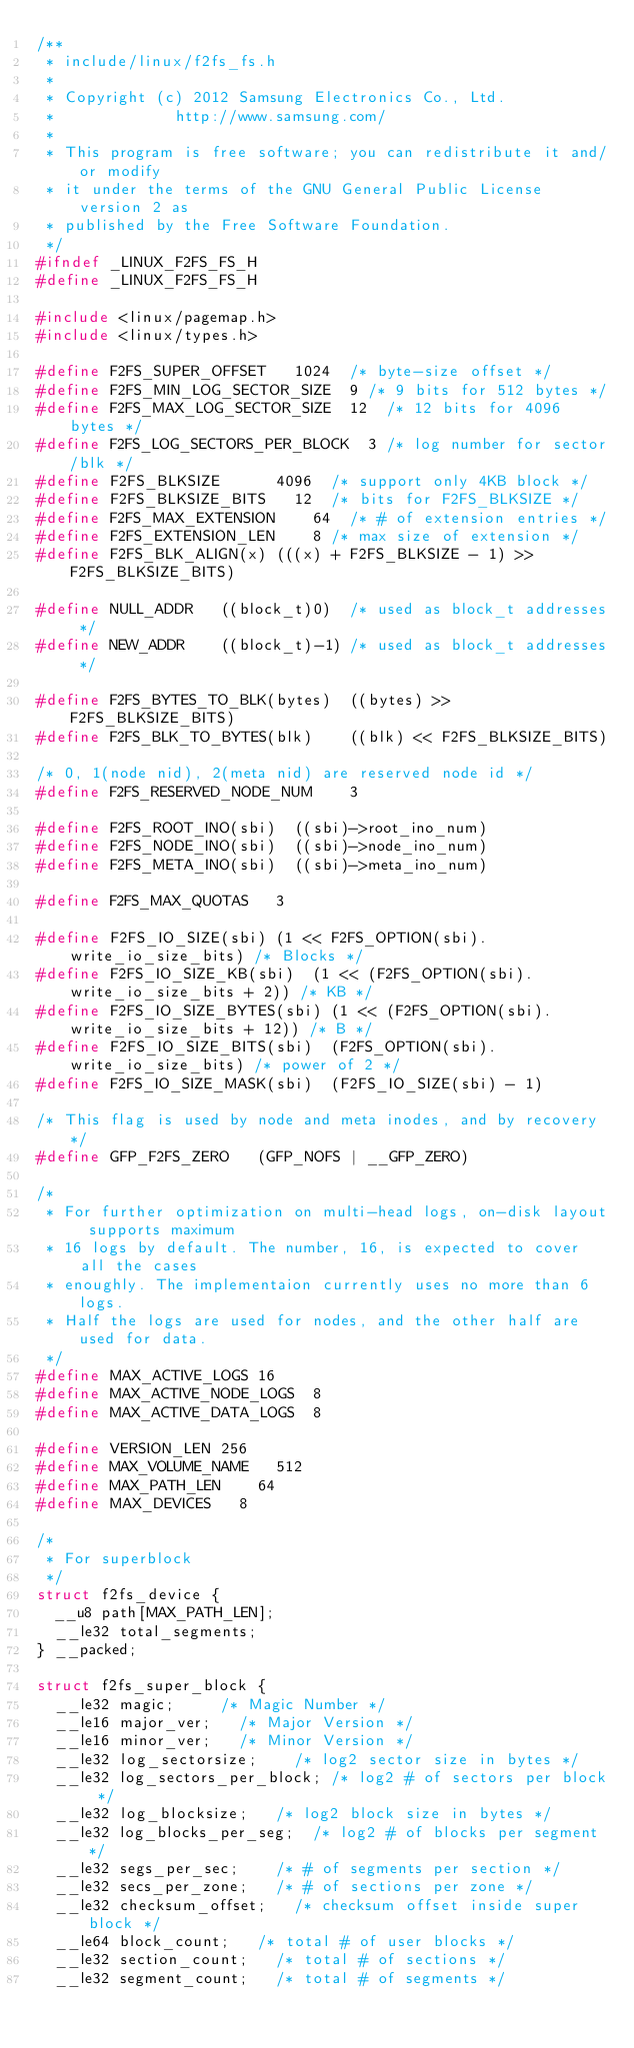Convert code to text. <code><loc_0><loc_0><loc_500><loc_500><_C_>/**
 * include/linux/f2fs_fs.h
 *
 * Copyright (c) 2012 Samsung Electronics Co., Ltd.
 *             http://www.samsung.com/
 *
 * This program is free software; you can redistribute it and/or modify
 * it under the terms of the GNU General Public License version 2 as
 * published by the Free Software Foundation.
 */
#ifndef _LINUX_F2FS_FS_H
#define _LINUX_F2FS_FS_H

#include <linux/pagemap.h>
#include <linux/types.h>

#define F2FS_SUPER_OFFSET		1024	/* byte-size offset */
#define F2FS_MIN_LOG_SECTOR_SIZE	9	/* 9 bits for 512 bytes */
#define F2FS_MAX_LOG_SECTOR_SIZE	12	/* 12 bits for 4096 bytes */
#define F2FS_LOG_SECTORS_PER_BLOCK	3	/* log number for sector/blk */
#define F2FS_BLKSIZE			4096	/* support only 4KB block */
#define F2FS_BLKSIZE_BITS		12	/* bits for F2FS_BLKSIZE */
#define F2FS_MAX_EXTENSION		64	/* # of extension entries */
#define F2FS_EXTENSION_LEN		8	/* max size of extension */
#define F2FS_BLK_ALIGN(x)	(((x) + F2FS_BLKSIZE - 1) >> F2FS_BLKSIZE_BITS)

#define NULL_ADDR		((block_t)0)	/* used as block_t addresses */
#define NEW_ADDR		((block_t)-1)	/* used as block_t addresses */

#define F2FS_BYTES_TO_BLK(bytes)	((bytes) >> F2FS_BLKSIZE_BITS)
#define F2FS_BLK_TO_BYTES(blk)		((blk) << F2FS_BLKSIZE_BITS)

/* 0, 1(node nid), 2(meta nid) are reserved node id */
#define F2FS_RESERVED_NODE_NUM		3

#define F2FS_ROOT_INO(sbi)	((sbi)->root_ino_num)
#define F2FS_NODE_INO(sbi)	((sbi)->node_ino_num)
#define F2FS_META_INO(sbi)	((sbi)->meta_ino_num)

#define F2FS_MAX_QUOTAS		3

#define F2FS_IO_SIZE(sbi)	(1 << F2FS_OPTION(sbi).write_io_size_bits) /* Blocks */
#define F2FS_IO_SIZE_KB(sbi)	(1 << (F2FS_OPTION(sbi).write_io_size_bits + 2)) /* KB */
#define F2FS_IO_SIZE_BYTES(sbi)	(1 << (F2FS_OPTION(sbi).write_io_size_bits + 12)) /* B */
#define F2FS_IO_SIZE_BITS(sbi)	(F2FS_OPTION(sbi).write_io_size_bits) /* power of 2 */
#define F2FS_IO_SIZE_MASK(sbi)	(F2FS_IO_SIZE(sbi) - 1)

/* This flag is used by node and meta inodes, and by recovery */
#define GFP_F2FS_ZERO		(GFP_NOFS | __GFP_ZERO)

/*
 * For further optimization on multi-head logs, on-disk layout supports maximum
 * 16 logs by default. The number, 16, is expected to cover all the cases
 * enoughly. The implementaion currently uses no more than 6 logs.
 * Half the logs are used for nodes, and the other half are used for data.
 */
#define MAX_ACTIVE_LOGS	16
#define MAX_ACTIVE_NODE_LOGS	8
#define MAX_ACTIVE_DATA_LOGS	8

#define VERSION_LEN	256
#define MAX_VOLUME_NAME		512
#define MAX_PATH_LEN		64
#define MAX_DEVICES		8

/*
 * For superblock
 */
struct f2fs_device {
	__u8 path[MAX_PATH_LEN];
	__le32 total_segments;
} __packed;

struct f2fs_super_block {
	__le32 magic;			/* Magic Number */
	__le16 major_ver;		/* Major Version */
	__le16 minor_ver;		/* Minor Version */
	__le32 log_sectorsize;		/* log2 sector size in bytes */
	__le32 log_sectors_per_block;	/* log2 # of sectors per block */
	__le32 log_blocksize;		/* log2 block size in bytes */
	__le32 log_blocks_per_seg;	/* log2 # of blocks per segment */
	__le32 segs_per_sec;		/* # of segments per section */
	__le32 secs_per_zone;		/* # of sections per zone */
	__le32 checksum_offset;		/* checksum offset inside super block */
	__le64 block_count;		/* total # of user blocks */
	__le32 section_count;		/* total # of sections */
	__le32 segment_count;		/* total # of segments */</code> 